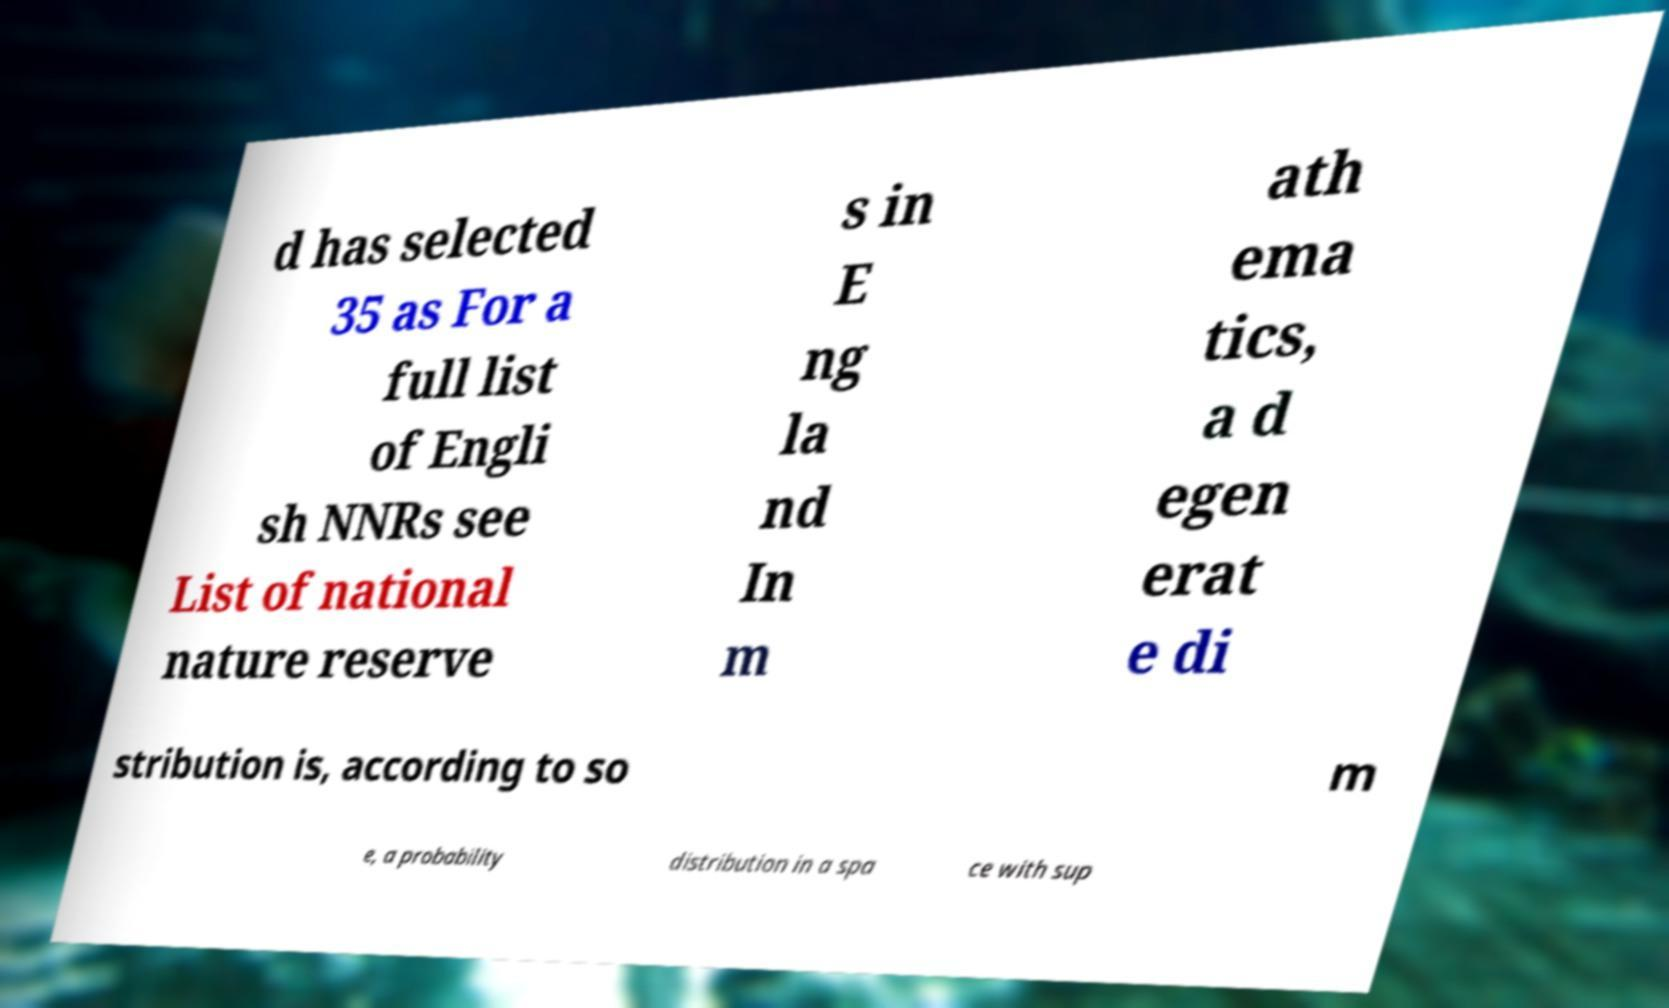Please identify and transcribe the text found in this image. d has selected 35 as For a full list of Engli sh NNRs see List of national nature reserve s in E ng la nd In m ath ema tics, a d egen erat e di stribution is, according to so m e, a probability distribution in a spa ce with sup 